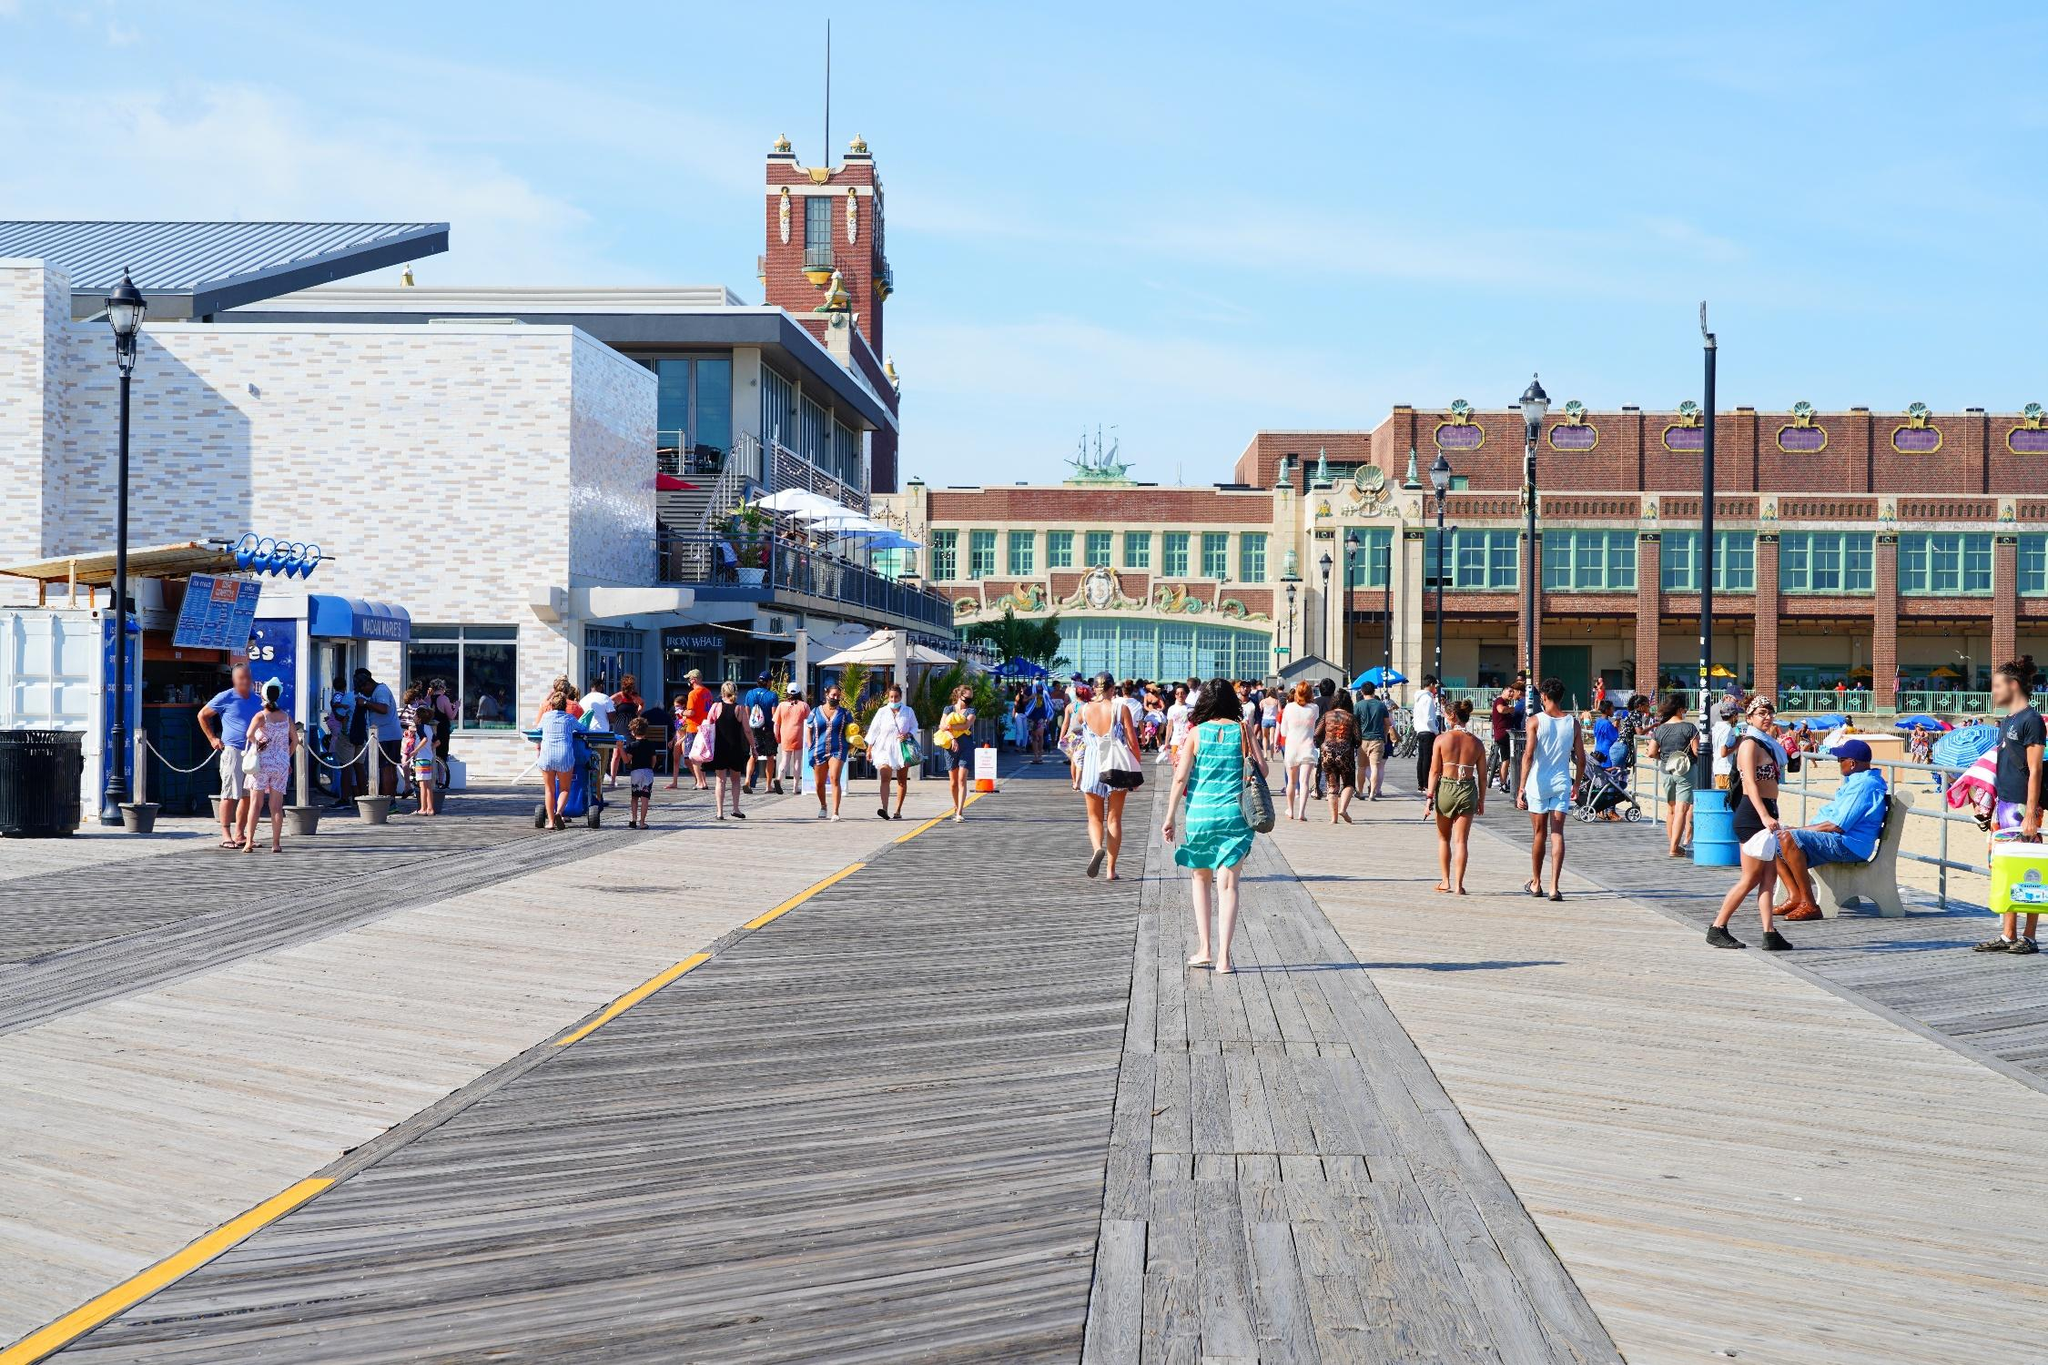Describe the people in the image and what they might be doing. The people in the image are engaged in various leisurely activities on the boardwalk. On the left, a small group waits in line at a food stand, likely purchasing refreshments or snacks. In the middle and towards the right, several individuals are walking together, enjoying a pleasant conversation as they stroll. Others are window-shopping, pausing to look at displays or deciding which shop to enter. A few people are seated, possibly taking a break and enjoying the view or simply people-watching. The overall impression is one of a vibrant and sociable atmosphere, with everyone enjoying a sunny day by the seaside. How does the presence of the clock tower influence the overall scene? The clock tower serves as a focal point in the scene, drawing the viewer's attention and providing a sense of orientation within the bustling boardwalk. Its imposing and historical appearance contrasts with the more modern structures around it, adding depth and a touch of grandeur to the overall atmosphere. The clock tower not only enhances the aesthetic appeal but also evokes a sense of time and history, reminding visitors of the area's rich cultural heritage and how it has evolved over the years. Imagine if the clock tower could speak. What stories would it tell? If the clock tower could speak, it would share tales from decades of witnessing the ebb and flow of life on the boardwalk. It would recount the early days when Asbury Park was a booming resort destination, with flappers and jazz musicians filling the air with energetic melodies and laughter. The tower would tell of the hard times during the Great Depression, when the boardwalk still provided a place of solace and hope for many. It might recall moments of heroism and community spirit during World War II, as residents and visitors alike came together in support of the troops. The clock tower might share stories of the cultural resurgence in the late 20th century, when music and art once again brought vibrancy to the boardwalk. Through all these eras, it has stood as a silent witness to the myriad of human experiences, capturing both the mundane and the extraordinary moments of life. 